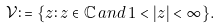Convert formula to latex. <formula><loc_0><loc_0><loc_500><loc_500>\mathcal { V } \colon = \{ z \colon z \in \mathbb { C } \, a n d \, 1 < | z | < \infty \} .</formula> 